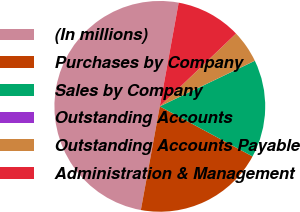Convert chart. <chart><loc_0><loc_0><loc_500><loc_500><pie_chart><fcel>(In millions)<fcel>Purchases by Company<fcel>Sales by Company<fcel>Outstanding Accounts<fcel>Outstanding Accounts Payable<fcel>Administration & Management<nl><fcel>49.99%<fcel>20.0%<fcel>15.0%<fcel>0.01%<fcel>5.01%<fcel>10.0%<nl></chart> 